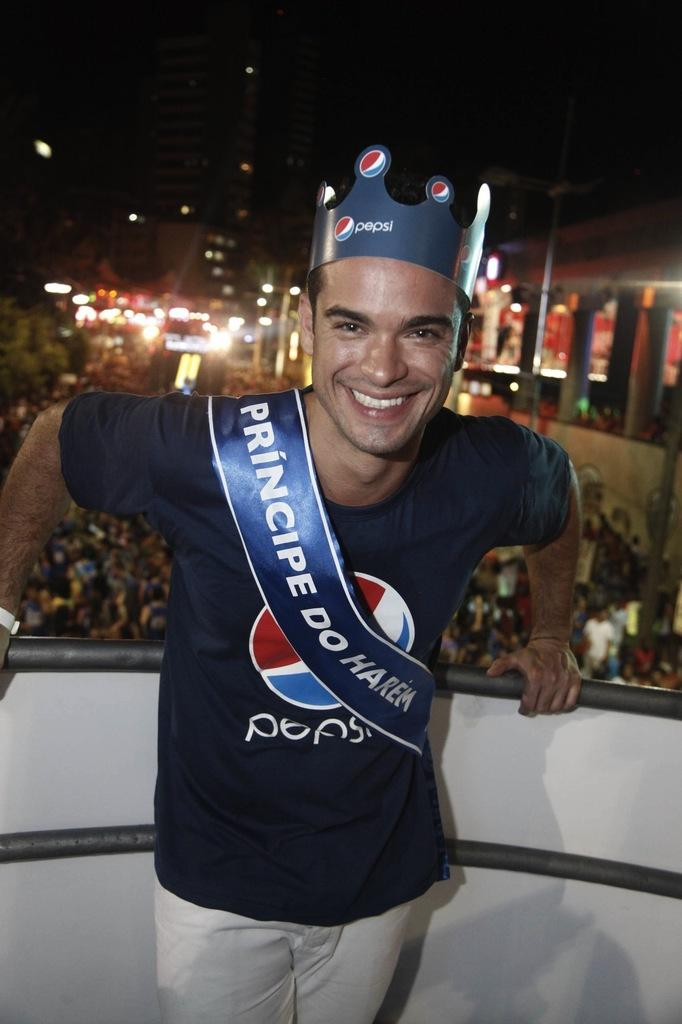<image>
Relay a brief, clear account of the picture shown. The male stands infront of a large crowd with a pepsi hat and t shirt on. 